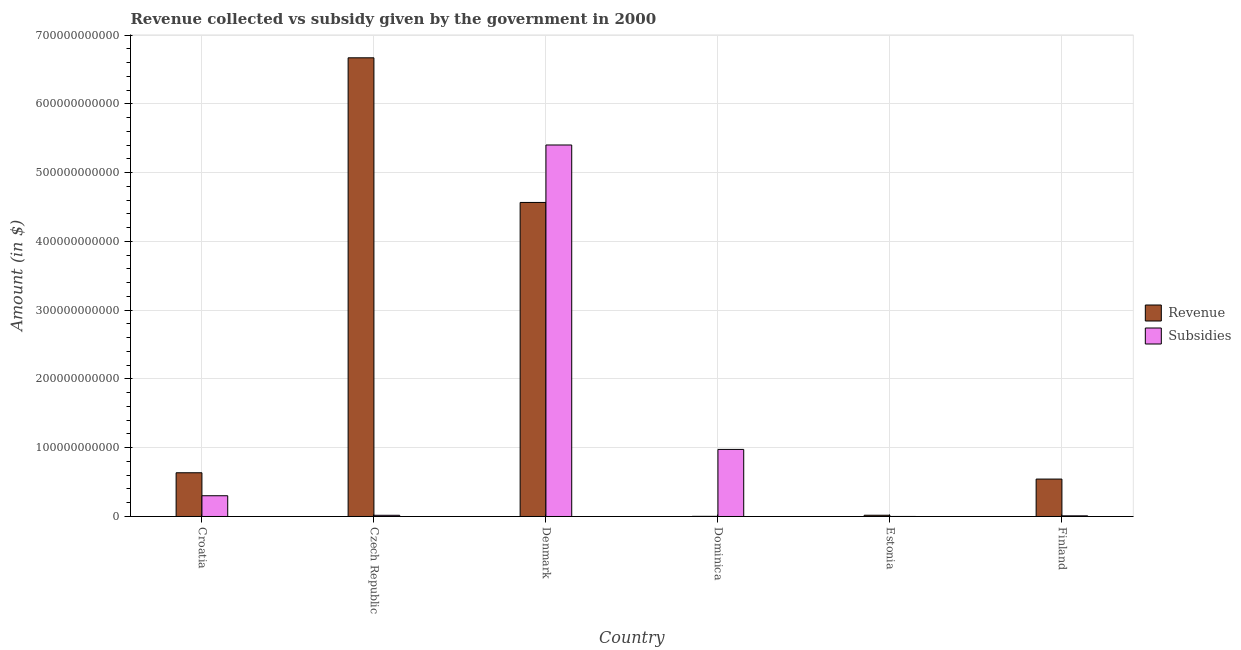How many different coloured bars are there?
Keep it short and to the point. 2. How many groups of bars are there?
Provide a succinct answer. 6. Are the number of bars per tick equal to the number of legend labels?
Give a very brief answer. Yes. How many bars are there on the 6th tick from the left?
Ensure brevity in your answer.  2. What is the label of the 6th group of bars from the left?
Provide a short and direct response. Finland. In how many cases, is the number of bars for a given country not equal to the number of legend labels?
Ensure brevity in your answer.  0. What is the amount of revenue collected in Finland?
Give a very brief answer. 5.44e+1. Across all countries, what is the maximum amount of revenue collected?
Offer a very short reply. 6.67e+11. Across all countries, what is the minimum amount of subsidies given?
Your answer should be compact. 3.78e+07. In which country was the amount of subsidies given minimum?
Your response must be concise. Estonia. What is the total amount of subsidies given in the graph?
Ensure brevity in your answer.  6.71e+11. What is the difference between the amount of revenue collected in Croatia and that in Denmark?
Provide a succinct answer. -3.93e+11. What is the difference between the amount of revenue collected in Dominica and the amount of subsidies given in Czech Republic?
Ensure brevity in your answer.  -1.53e+09. What is the average amount of revenue collected per country?
Keep it short and to the point. 2.07e+11. What is the difference between the amount of revenue collected and amount of subsidies given in Dominica?
Keep it short and to the point. -9.73e+1. In how many countries, is the amount of revenue collected greater than 60000000000 $?
Provide a succinct answer. 3. What is the ratio of the amount of revenue collected in Czech Republic to that in Finland?
Ensure brevity in your answer.  12.26. Is the amount of subsidies given in Dominica less than that in Estonia?
Make the answer very short. No. Is the difference between the amount of subsidies given in Croatia and Dominica greater than the difference between the amount of revenue collected in Croatia and Dominica?
Your response must be concise. No. What is the difference between the highest and the second highest amount of revenue collected?
Make the answer very short. 2.10e+11. What is the difference between the highest and the lowest amount of revenue collected?
Provide a succinct answer. 6.67e+11. In how many countries, is the amount of subsidies given greater than the average amount of subsidies given taken over all countries?
Your response must be concise. 1. Is the sum of the amount of subsidies given in Dominica and Finland greater than the maximum amount of revenue collected across all countries?
Your answer should be compact. No. What does the 2nd bar from the left in Finland represents?
Your answer should be very brief. Subsidies. What does the 1st bar from the right in Croatia represents?
Provide a short and direct response. Subsidies. What is the difference between two consecutive major ticks on the Y-axis?
Your response must be concise. 1.00e+11. Does the graph contain any zero values?
Your answer should be very brief. No. Where does the legend appear in the graph?
Give a very brief answer. Center right. How many legend labels are there?
Your response must be concise. 2. How are the legend labels stacked?
Your answer should be compact. Vertical. What is the title of the graph?
Keep it short and to the point. Revenue collected vs subsidy given by the government in 2000. What is the label or title of the Y-axis?
Offer a terse response. Amount (in $). What is the Amount (in $) of Revenue in Croatia?
Your response must be concise. 6.36e+1. What is the Amount (in $) of Subsidies in Croatia?
Provide a short and direct response. 3.02e+1. What is the Amount (in $) in Revenue in Czech Republic?
Keep it short and to the point. 6.67e+11. What is the Amount (in $) in Subsidies in Czech Republic?
Your answer should be compact. 1.74e+09. What is the Amount (in $) of Revenue in Denmark?
Give a very brief answer. 4.57e+11. What is the Amount (in $) in Subsidies in Denmark?
Keep it short and to the point. 5.40e+11. What is the Amount (in $) of Revenue in Dominica?
Give a very brief answer. 2.14e+08. What is the Amount (in $) in Subsidies in Dominica?
Your answer should be compact. 9.75e+1. What is the Amount (in $) of Revenue in Estonia?
Your response must be concise. 1.81e+09. What is the Amount (in $) of Subsidies in Estonia?
Provide a short and direct response. 3.78e+07. What is the Amount (in $) of Revenue in Finland?
Your response must be concise. 5.44e+1. What is the Amount (in $) in Subsidies in Finland?
Give a very brief answer. 9.37e+08. Across all countries, what is the maximum Amount (in $) in Revenue?
Provide a short and direct response. 6.67e+11. Across all countries, what is the maximum Amount (in $) in Subsidies?
Your answer should be very brief. 5.40e+11. Across all countries, what is the minimum Amount (in $) in Revenue?
Keep it short and to the point. 2.14e+08. Across all countries, what is the minimum Amount (in $) of Subsidies?
Provide a succinct answer. 3.78e+07. What is the total Amount (in $) of Revenue in the graph?
Make the answer very short. 1.24e+12. What is the total Amount (in $) in Subsidies in the graph?
Give a very brief answer. 6.71e+11. What is the difference between the Amount (in $) in Revenue in Croatia and that in Czech Republic?
Ensure brevity in your answer.  -6.03e+11. What is the difference between the Amount (in $) of Subsidies in Croatia and that in Czech Republic?
Keep it short and to the point. 2.84e+1. What is the difference between the Amount (in $) of Revenue in Croatia and that in Denmark?
Your answer should be compact. -3.93e+11. What is the difference between the Amount (in $) of Subsidies in Croatia and that in Denmark?
Make the answer very short. -5.10e+11. What is the difference between the Amount (in $) in Revenue in Croatia and that in Dominica?
Provide a succinct answer. 6.34e+1. What is the difference between the Amount (in $) of Subsidies in Croatia and that in Dominica?
Offer a very short reply. -6.74e+1. What is the difference between the Amount (in $) in Revenue in Croatia and that in Estonia?
Ensure brevity in your answer.  6.18e+1. What is the difference between the Amount (in $) in Subsidies in Croatia and that in Estonia?
Your answer should be compact. 3.01e+1. What is the difference between the Amount (in $) of Revenue in Croatia and that in Finland?
Give a very brief answer. 9.18e+09. What is the difference between the Amount (in $) in Subsidies in Croatia and that in Finland?
Make the answer very short. 2.92e+1. What is the difference between the Amount (in $) of Revenue in Czech Republic and that in Denmark?
Your answer should be compact. 2.10e+11. What is the difference between the Amount (in $) in Subsidies in Czech Republic and that in Denmark?
Offer a very short reply. -5.38e+11. What is the difference between the Amount (in $) in Revenue in Czech Republic and that in Dominica?
Provide a short and direct response. 6.67e+11. What is the difference between the Amount (in $) of Subsidies in Czech Republic and that in Dominica?
Offer a very short reply. -9.58e+1. What is the difference between the Amount (in $) of Revenue in Czech Republic and that in Estonia?
Provide a succinct answer. 6.65e+11. What is the difference between the Amount (in $) of Subsidies in Czech Republic and that in Estonia?
Make the answer very short. 1.70e+09. What is the difference between the Amount (in $) of Revenue in Czech Republic and that in Finland?
Your answer should be compact. 6.13e+11. What is the difference between the Amount (in $) of Subsidies in Czech Republic and that in Finland?
Provide a succinct answer. 8.06e+08. What is the difference between the Amount (in $) of Revenue in Denmark and that in Dominica?
Make the answer very short. 4.56e+11. What is the difference between the Amount (in $) of Subsidies in Denmark and that in Dominica?
Your answer should be very brief. 4.43e+11. What is the difference between the Amount (in $) of Revenue in Denmark and that in Estonia?
Give a very brief answer. 4.55e+11. What is the difference between the Amount (in $) of Subsidies in Denmark and that in Estonia?
Your answer should be very brief. 5.40e+11. What is the difference between the Amount (in $) of Revenue in Denmark and that in Finland?
Offer a very short reply. 4.02e+11. What is the difference between the Amount (in $) in Subsidies in Denmark and that in Finland?
Your answer should be very brief. 5.39e+11. What is the difference between the Amount (in $) of Revenue in Dominica and that in Estonia?
Your answer should be very brief. -1.60e+09. What is the difference between the Amount (in $) in Subsidies in Dominica and that in Estonia?
Give a very brief answer. 9.75e+1. What is the difference between the Amount (in $) in Revenue in Dominica and that in Finland?
Your answer should be compact. -5.42e+1. What is the difference between the Amount (in $) in Subsidies in Dominica and that in Finland?
Your answer should be compact. 9.66e+1. What is the difference between the Amount (in $) of Revenue in Estonia and that in Finland?
Your answer should be compact. -5.26e+1. What is the difference between the Amount (in $) in Subsidies in Estonia and that in Finland?
Ensure brevity in your answer.  -8.99e+08. What is the difference between the Amount (in $) in Revenue in Croatia and the Amount (in $) in Subsidies in Czech Republic?
Provide a short and direct response. 6.18e+1. What is the difference between the Amount (in $) of Revenue in Croatia and the Amount (in $) of Subsidies in Denmark?
Your response must be concise. -4.77e+11. What is the difference between the Amount (in $) in Revenue in Croatia and the Amount (in $) in Subsidies in Dominica?
Your answer should be compact. -3.40e+1. What is the difference between the Amount (in $) in Revenue in Croatia and the Amount (in $) in Subsidies in Estonia?
Offer a terse response. 6.35e+1. What is the difference between the Amount (in $) in Revenue in Croatia and the Amount (in $) in Subsidies in Finland?
Provide a succinct answer. 6.26e+1. What is the difference between the Amount (in $) of Revenue in Czech Republic and the Amount (in $) of Subsidies in Denmark?
Your answer should be very brief. 1.27e+11. What is the difference between the Amount (in $) in Revenue in Czech Republic and the Amount (in $) in Subsidies in Dominica?
Keep it short and to the point. 5.69e+11. What is the difference between the Amount (in $) in Revenue in Czech Republic and the Amount (in $) in Subsidies in Estonia?
Your answer should be compact. 6.67e+11. What is the difference between the Amount (in $) in Revenue in Czech Republic and the Amount (in $) in Subsidies in Finland?
Offer a very short reply. 6.66e+11. What is the difference between the Amount (in $) in Revenue in Denmark and the Amount (in $) in Subsidies in Dominica?
Keep it short and to the point. 3.59e+11. What is the difference between the Amount (in $) in Revenue in Denmark and the Amount (in $) in Subsidies in Estonia?
Offer a very short reply. 4.57e+11. What is the difference between the Amount (in $) in Revenue in Denmark and the Amount (in $) in Subsidies in Finland?
Provide a succinct answer. 4.56e+11. What is the difference between the Amount (in $) in Revenue in Dominica and the Amount (in $) in Subsidies in Estonia?
Your response must be concise. 1.76e+08. What is the difference between the Amount (in $) of Revenue in Dominica and the Amount (in $) of Subsidies in Finland?
Ensure brevity in your answer.  -7.23e+08. What is the difference between the Amount (in $) of Revenue in Estonia and the Amount (in $) of Subsidies in Finland?
Offer a terse response. 8.72e+08. What is the average Amount (in $) in Revenue per country?
Your response must be concise. 2.07e+11. What is the average Amount (in $) of Subsidies per country?
Provide a short and direct response. 1.12e+11. What is the difference between the Amount (in $) in Revenue and Amount (in $) in Subsidies in Croatia?
Offer a terse response. 3.34e+1. What is the difference between the Amount (in $) in Revenue and Amount (in $) in Subsidies in Czech Republic?
Your answer should be very brief. 6.65e+11. What is the difference between the Amount (in $) of Revenue and Amount (in $) of Subsidies in Denmark?
Provide a short and direct response. -8.35e+1. What is the difference between the Amount (in $) in Revenue and Amount (in $) in Subsidies in Dominica?
Ensure brevity in your answer.  -9.73e+1. What is the difference between the Amount (in $) in Revenue and Amount (in $) in Subsidies in Estonia?
Your answer should be compact. 1.77e+09. What is the difference between the Amount (in $) in Revenue and Amount (in $) in Subsidies in Finland?
Ensure brevity in your answer.  5.35e+1. What is the ratio of the Amount (in $) in Revenue in Croatia to that in Czech Republic?
Your answer should be very brief. 0.1. What is the ratio of the Amount (in $) in Subsidies in Croatia to that in Czech Republic?
Your answer should be compact. 17.31. What is the ratio of the Amount (in $) of Revenue in Croatia to that in Denmark?
Offer a very short reply. 0.14. What is the ratio of the Amount (in $) of Subsidies in Croatia to that in Denmark?
Offer a terse response. 0.06. What is the ratio of the Amount (in $) of Revenue in Croatia to that in Dominica?
Your answer should be compact. 297.5. What is the ratio of the Amount (in $) in Subsidies in Croatia to that in Dominica?
Provide a succinct answer. 0.31. What is the ratio of the Amount (in $) of Revenue in Croatia to that in Estonia?
Provide a short and direct response. 35.14. What is the ratio of the Amount (in $) of Subsidies in Croatia to that in Estonia?
Provide a succinct answer. 798.04. What is the ratio of the Amount (in $) of Revenue in Croatia to that in Finland?
Your answer should be compact. 1.17. What is the ratio of the Amount (in $) of Subsidies in Croatia to that in Finland?
Provide a succinct answer. 32.21. What is the ratio of the Amount (in $) in Revenue in Czech Republic to that in Denmark?
Make the answer very short. 1.46. What is the ratio of the Amount (in $) in Subsidies in Czech Republic to that in Denmark?
Your answer should be very brief. 0. What is the ratio of the Amount (in $) of Revenue in Czech Republic to that in Dominica?
Your response must be concise. 3120.93. What is the ratio of the Amount (in $) in Subsidies in Czech Republic to that in Dominica?
Keep it short and to the point. 0.02. What is the ratio of the Amount (in $) in Revenue in Czech Republic to that in Estonia?
Your response must be concise. 368.68. What is the ratio of the Amount (in $) in Subsidies in Czech Republic to that in Estonia?
Your response must be concise. 46.1. What is the ratio of the Amount (in $) of Revenue in Czech Republic to that in Finland?
Your response must be concise. 12.26. What is the ratio of the Amount (in $) in Subsidies in Czech Republic to that in Finland?
Offer a terse response. 1.86. What is the ratio of the Amount (in $) of Revenue in Denmark to that in Dominica?
Offer a very short reply. 2136.8. What is the ratio of the Amount (in $) of Subsidies in Denmark to that in Dominica?
Offer a very short reply. 5.54. What is the ratio of the Amount (in $) of Revenue in Denmark to that in Estonia?
Keep it short and to the point. 252.42. What is the ratio of the Amount (in $) of Subsidies in Denmark to that in Estonia?
Give a very brief answer. 1.43e+04. What is the ratio of the Amount (in $) of Revenue in Denmark to that in Finland?
Ensure brevity in your answer.  8.4. What is the ratio of the Amount (in $) in Subsidies in Denmark to that in Finland?
Provide a short and direct response. 576.74. What is the ratio of the Amount (in $) in Revenue in Dominica to that in Estonia?
Make the answer very short. 0.12. What is the ratio of the Amount (in $) in Subsidies in Dominica to that in Estonia?
Make the answer very short. 2580.05. What is the ratio of the Amount (in $) of Revenue in Dominica to that in Finland?
Offer a terse response. 0. What is the ratio of the Amount (in $) in Subsidies in Dominica to that in Finland?
Your answer should be compact. 104.13. What is the ratio of the Amount (in $) of Subsidies in Estonia to that in Finland?
Ensure brevity in your answer.  0.04. What is the difference between the highest and the second highest Amount (in $) of Revenue?
Your response must be concise. 2.10e+11. What is the difference between the highest and the second highest Amount (in $) of Subsidies?
Your response must be concise. 4.43e+11. What is the difference between the highest and the lowest Amount (in $) in Revenue?
Your answer should be compact. 6.67e+11. What is the difference between the highest and the lowest Amount (in $) in Subsidies?
Ensure brevity in your answer.  5.40e+11. 